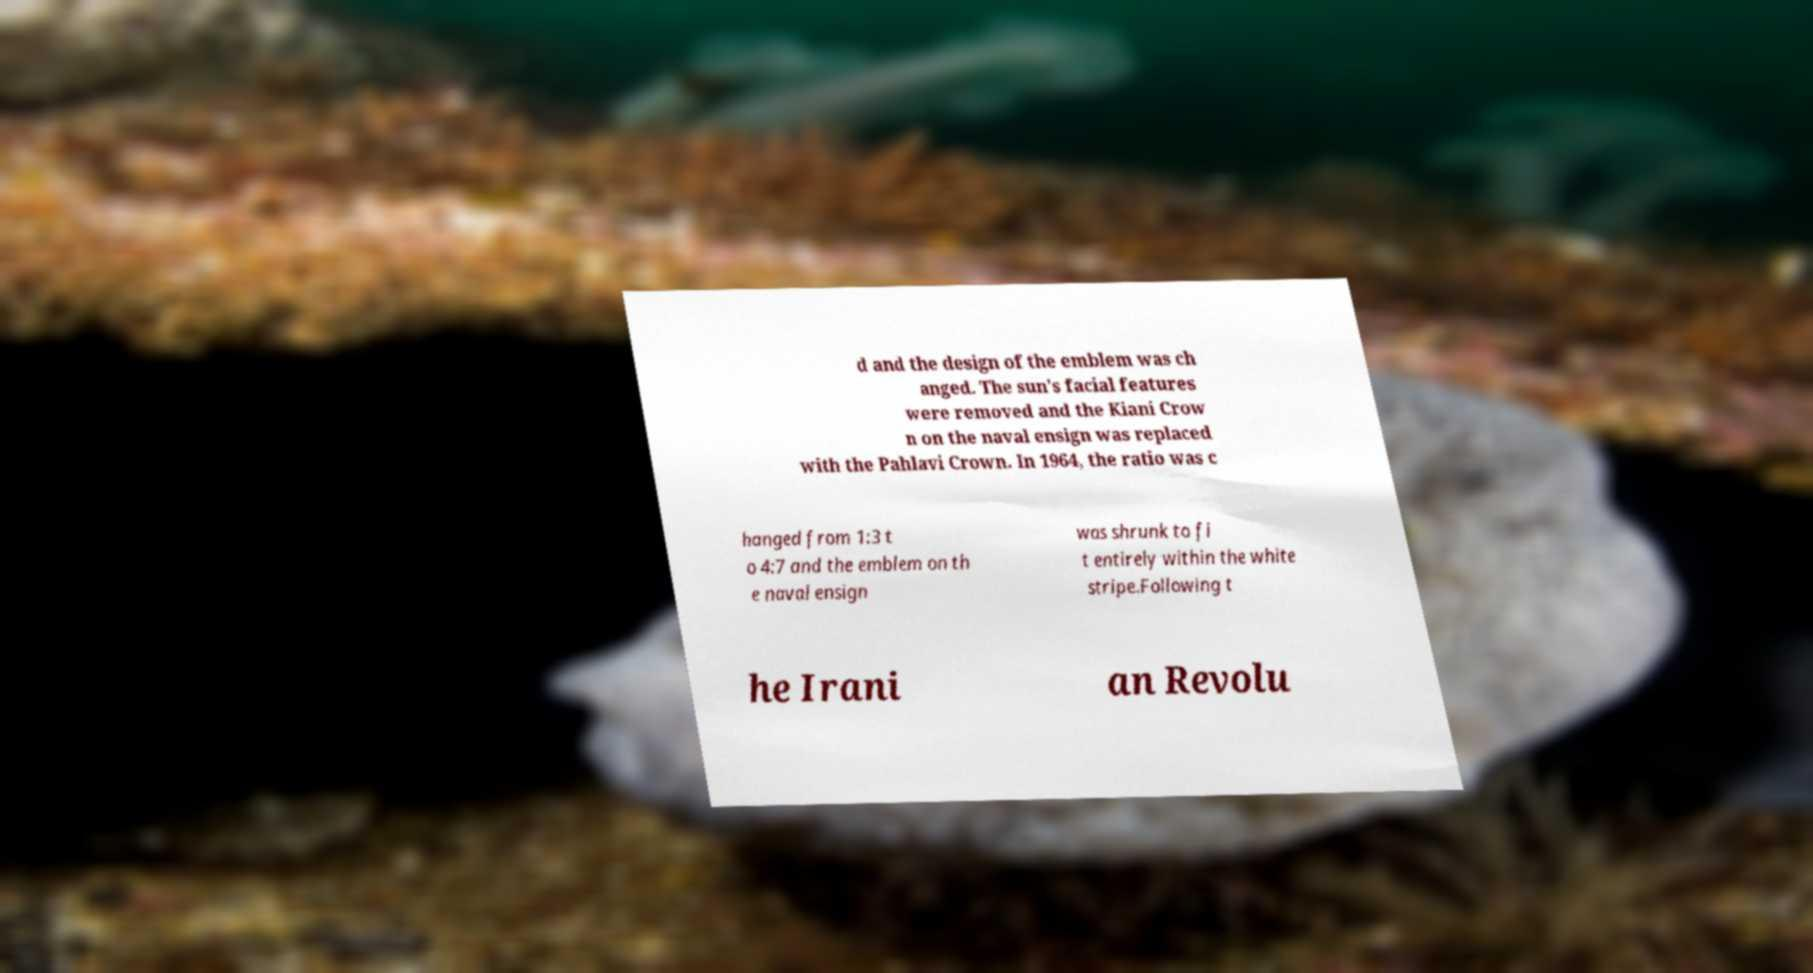What messages or text are displayed in this image? I need them in a readable, typed format. d and the design of the emblem was ch anged. The sun's facial features were removed and the Kiani Crow n on the naval ensign was replaced with the Pahlavi Crown. In 1964, the ratio was c hanged from 1:3 t o 4:7 and the emblem on th e naval ensign was shrunk to fi t entirely within the white stripe.Following t he Irani an Revolu 